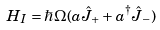Convert formula to latex. <formula><loc_0><loc_0><loc_500><loc_500>H _ { I } = \hbar { \Omega } ( a \hat { J } _ { + } + a ^ { \dagger } \hat { J } _ { - } )</formula> 